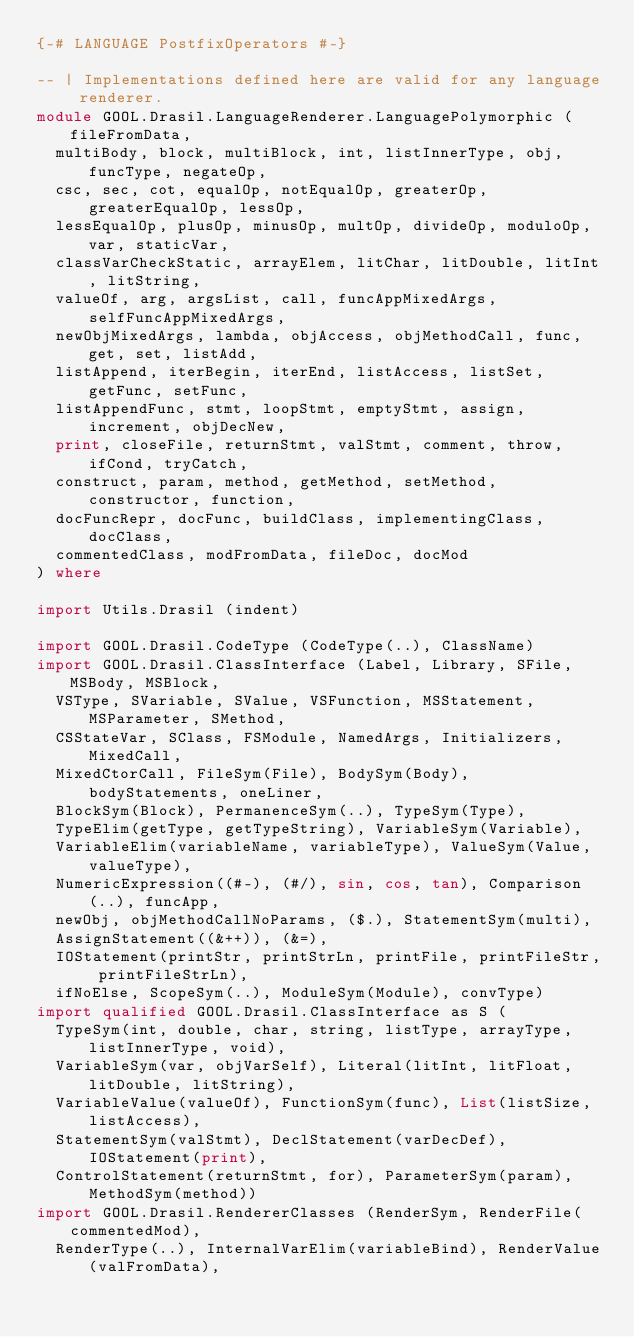Convert code to text. <code><loc_0><loc_0><loc_500><loc_500><_Haskell_>{-# LANGUAGE PostfixOperators #-}

-- | Implementations defined here are valid for any language renderer.
module GOOL.Drasil.LanguageRenderer.LanguagePolymorphic (fileFromData,
  multiBody, block, multiBlock, int, listInnerType, obj, funcType, negateOp, 
  csc, sec, cot, equalOp, notEqualOp, greaterOp, greaterEqualOp, lessOp, 
  lessEqualOp, plusOp, minusOp, multOp, divideOp, moduloOp, var, staticVar, 
  classVarCheckStatic, arrayElem, litChar, litDouble, litInt, litString, 
  valueOf, arg, argsList, call, funcAppMixedArgs, selfFuncAppMixedArgs, 
  newObjMixedArgs, lambda, objAccess, objMethodCall, func, get, set, listAdd, 
  listAppend, iterBegin, iterEnd, listAccess, listSet, getFunc, setFunc, 
  listAppendFunc, stmt, loopStmt, emptyStmt, assign, increment, objDecNew, 
  print, closeFile, returnStmt, valStmt, comment, throw, ifCond, tryCatch, 
  construct, param, method, getMethod, setMethod, constructor, function, 
  docFuncRepr, docFunc, buildClass, implementingClass, docClass, 
  commentedClass, modFromData, fileDoc, docMod
) where

import Utils.Drasil (indent)

import GOOL.Drasil.CodeType (CodeType(..), ClassName)
import GOOL.Drasil.ClassInterface (Label, Library, SFile, MSBody, MSBlock, 
  VSType, SVariable, SValue, VSFunction, MSStatement, MSParameter, SMethod, 
  CSStateVar, SClass, FSModule, NamedArgs, Initializers, MixedCall, 
  MixedCtorCall, FileSym(File), BodySym(Body), bodyStatements, oneLiner, 
  BlockSym(Block), PermanenceSym(..), TypeSym(Type), 
  TypeElim(getType, getTypeString), VariableSym(Variable), 
  VariableElim(variableName, variableType), ValueSym(Value, valueType), 
  NumericExpression((#-), (#/), sin, cos, tan), Comparison(..), funcApp, 
  newObj, objMethodCallNoParams, ($.), StatementSym(multi), 
  AssignStatement((&++)), (&=), 
  IOStatement(printStr, printStrLn, printFile, printFileStr, printFileStrLn),
  ifNoElse, ScopeSym(..), ModuleSym(Module), convType)
import qualified GOOL.Drasil.ClassInterface as S (
  TypeSym(int, double, char, string, listType, arrayType, listInnerType, void), 
  VariableSym(var, objVarSelf), Literal(litInt, litFloat, litDouble, litString),
  VariableValue(valueOf), FunctionSym(func), List(listSize, listAccess), 
  StatementSym(valStmt), DeclStatement(varDecDef), IOStatement(print),
  ControlStatement(returnStmt, for), ParameterSym(param), MethodSym(method))
import GOOL.Drasil.RendererClasses (RenderSym, RenderFile(commentedMod),  
  RenderType(..), InternalVarElim(variableBind), RenderValue(valFromData),</code> 